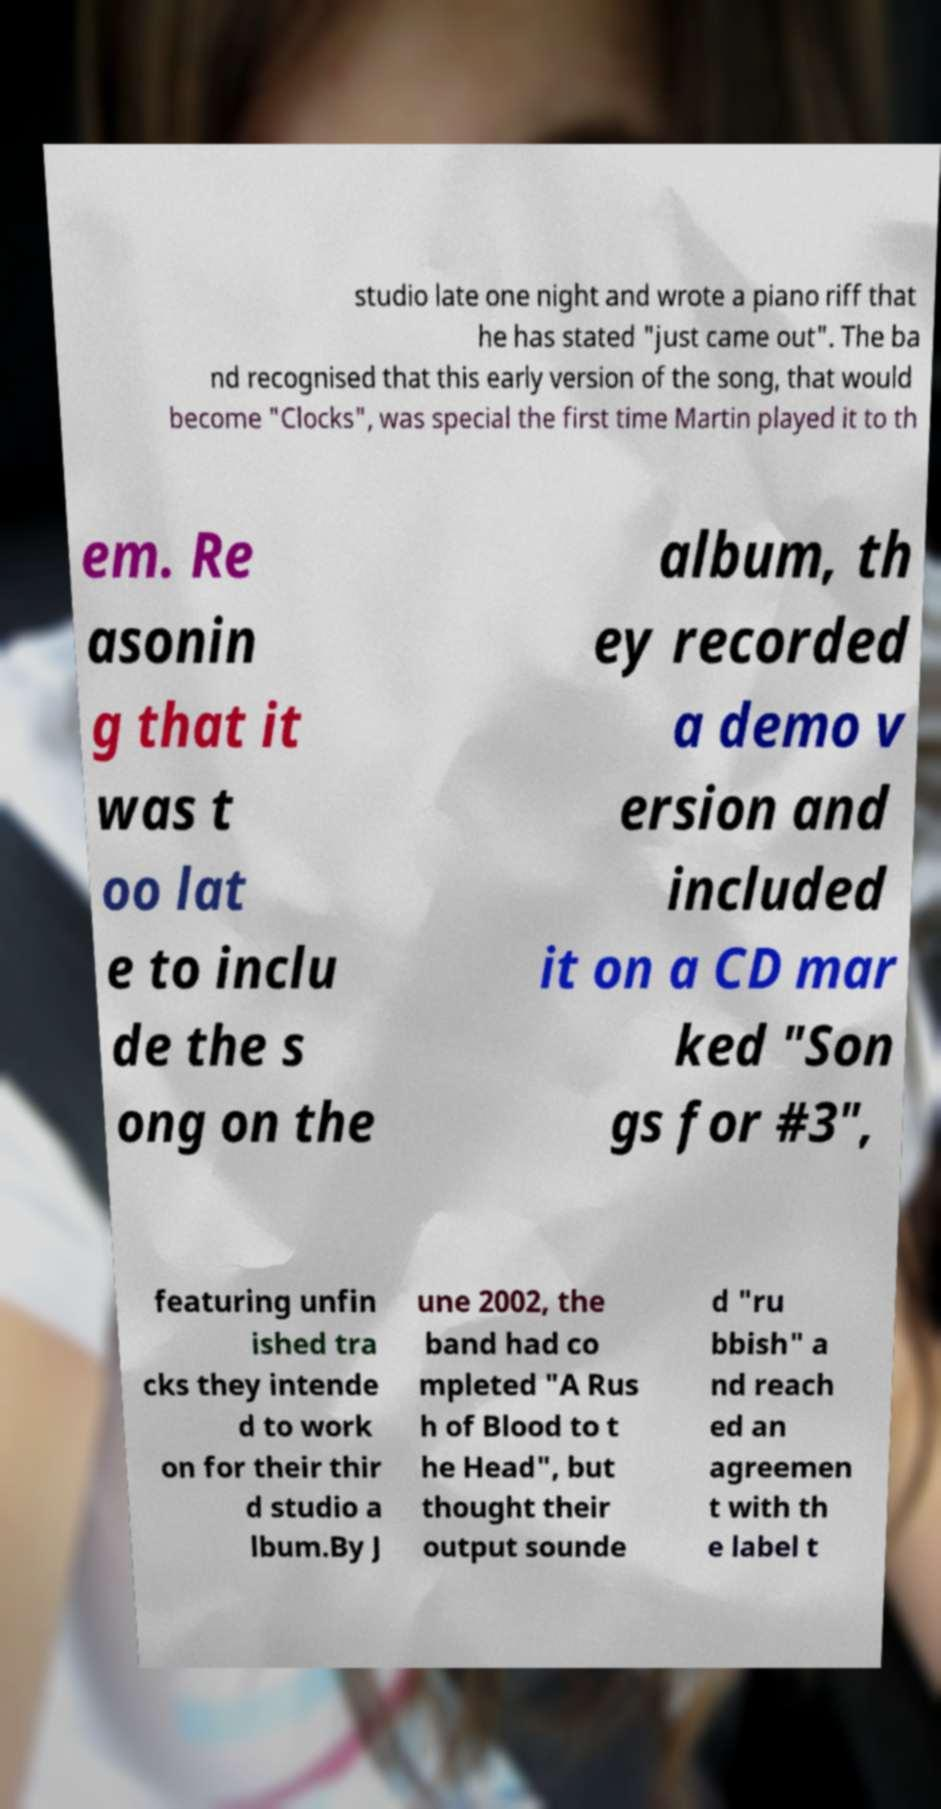Can you accurately transcribe the text from the provided image for me? studio late one night and wrote a piano riff that he has stated "just came out". The ba nd recognised that this early version of the song, that would become "Clocks", was special the first time Martin played it to th em. Re asonin g that it was t oo lat e to inclu de the s ong on the album, th ey recorded a demo v ersion and included it on a CD mar ked "Son gs for #3", featuring unfin ished tra cks they intende d to work on for their thir d studio a lbum.By J une 2002, the band had co mpleted "A Rus h of Blood to t he Head", but thought their output sounde d "ru bbish" a nd reach ed an agreemen t with th e label t 